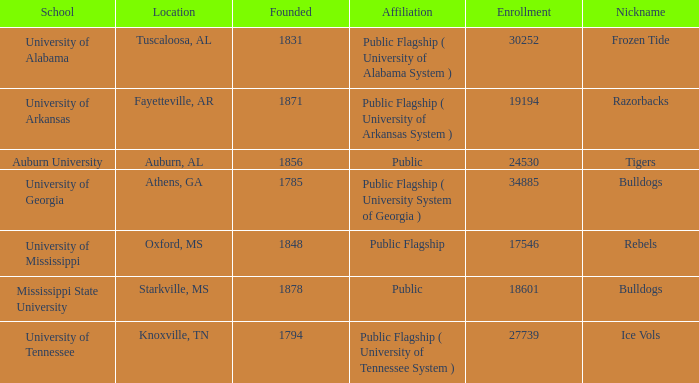What is the highest capacity for student enrollment in the schools? 34885.0. 